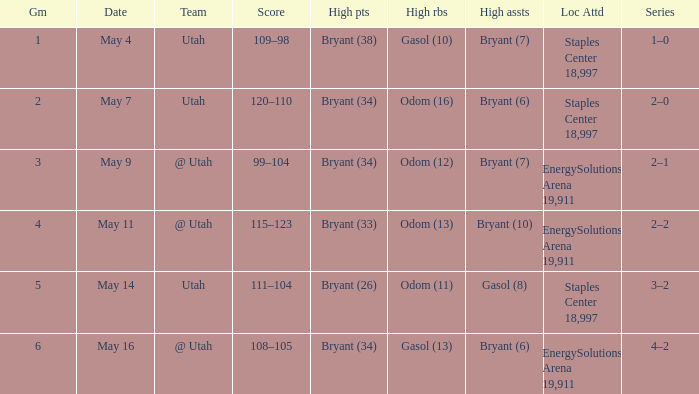What is the Series with a High rebounds with gasol (10)? 1–0. 